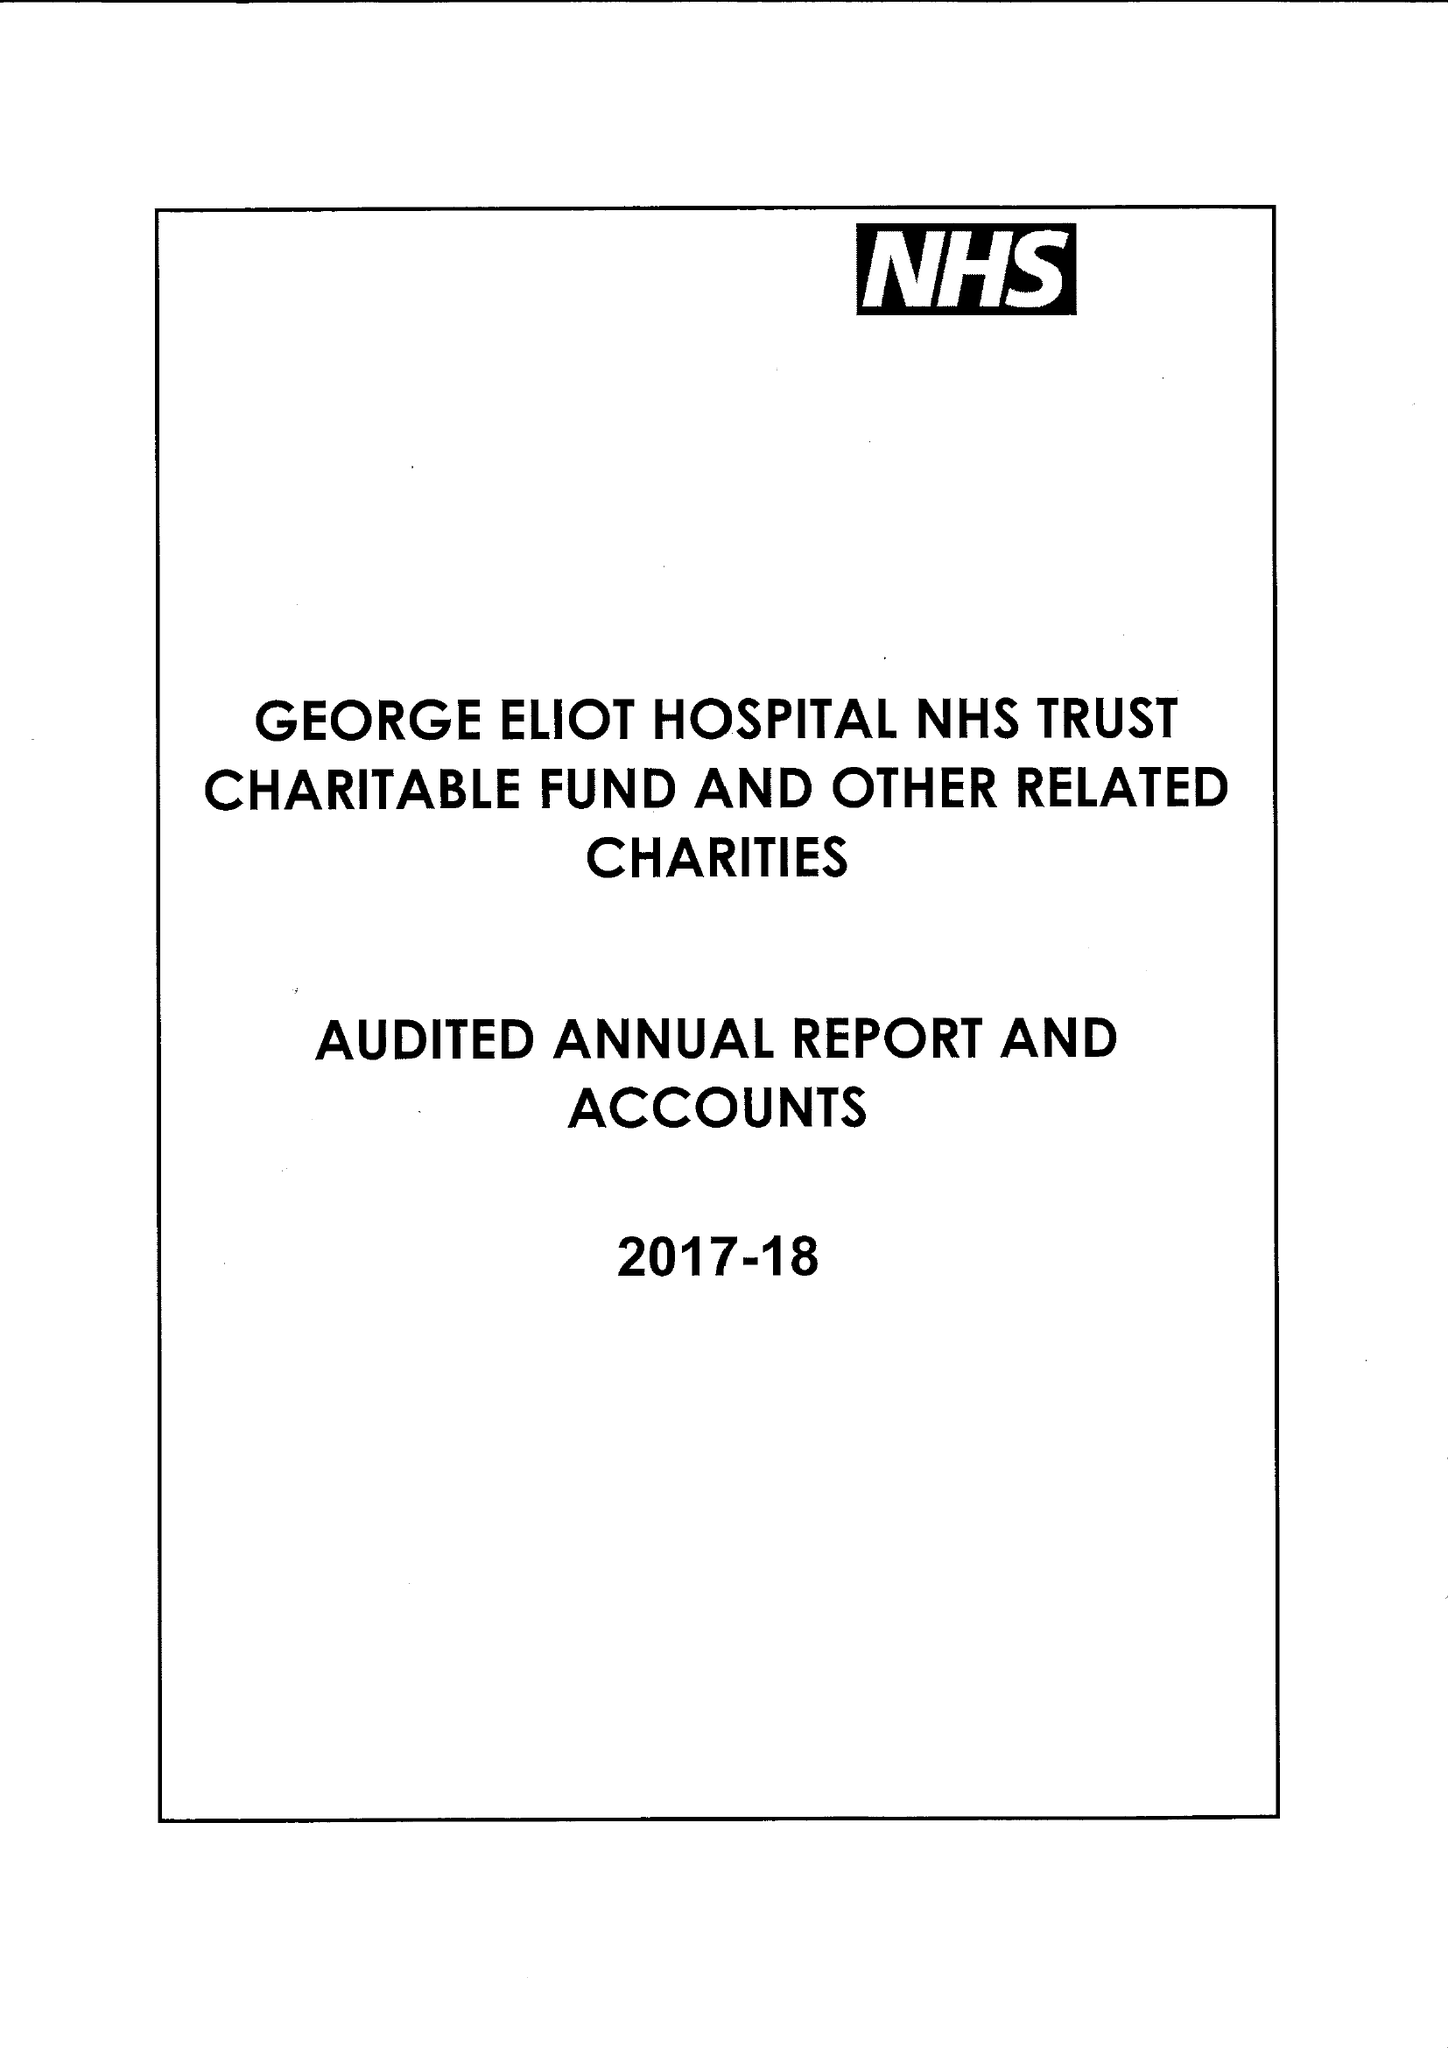What is the value for the charity_number?
Answer the question using a single word or phrase. 1057607 